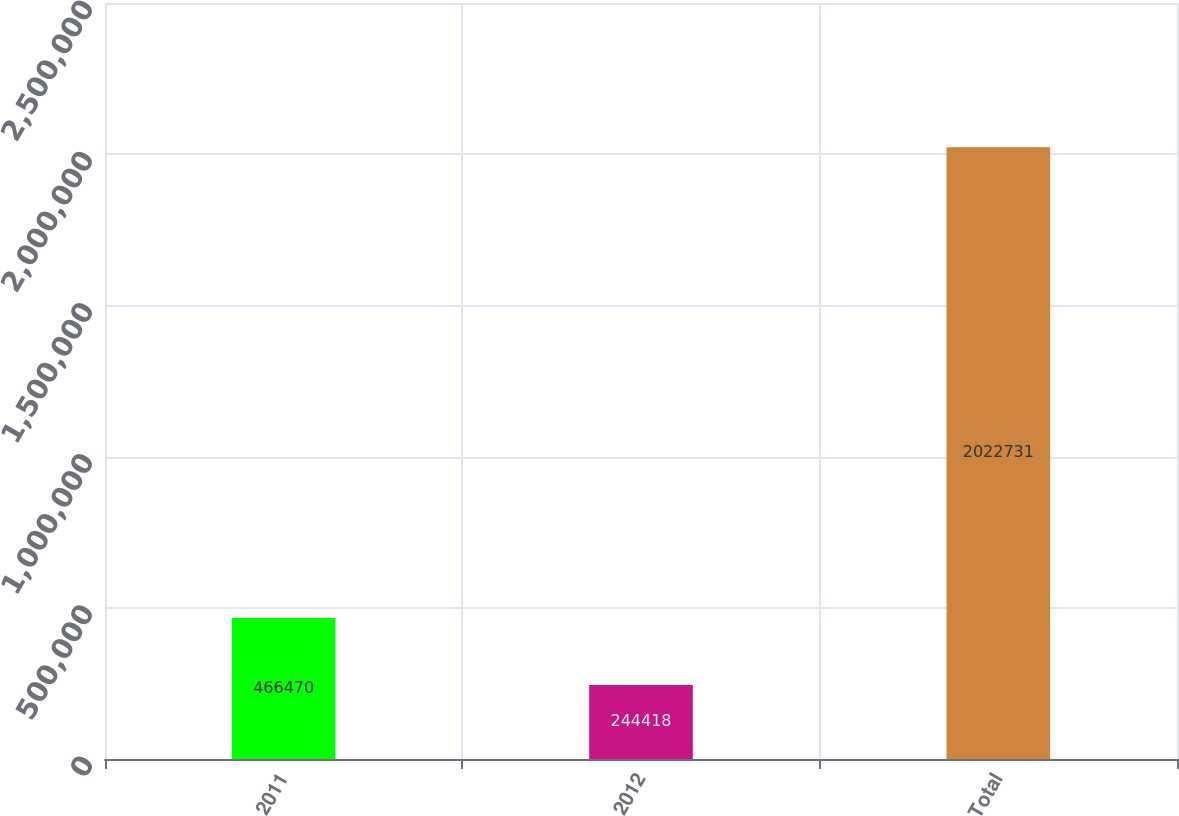Convert chart to OTSL. <chart><loc_0><loc_0><loc_500><loc_500><bar_chart><fcel>2011<fcel>2012<fcel>Total<nl><fcel>466470<fcel>244418<fcel>2.02273e+06<nl></chart> 